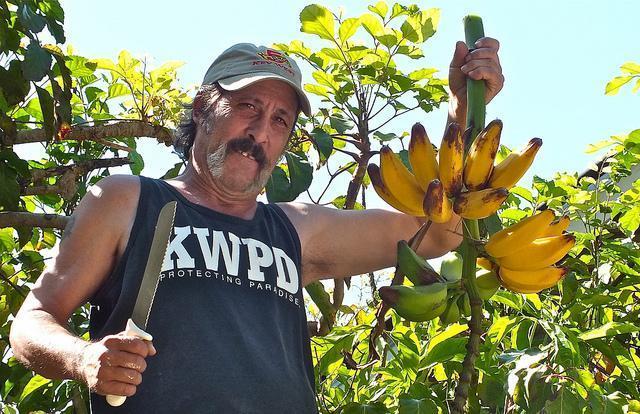How many bananas are in the photo?
Give a very brief answer. 2. 